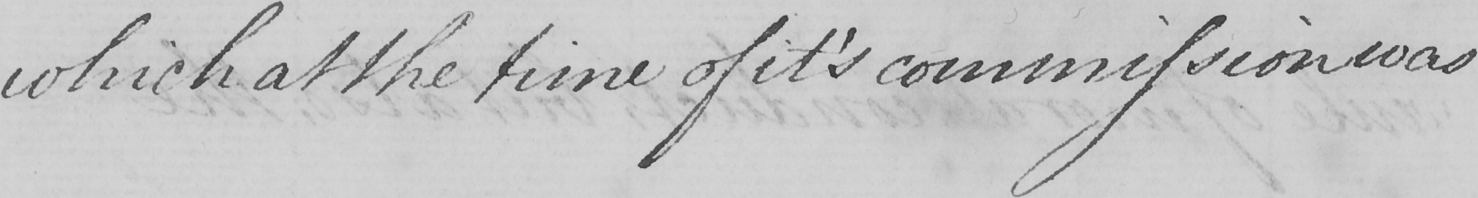What text is written in this handwritten line? which at the time of it ' s commission was 